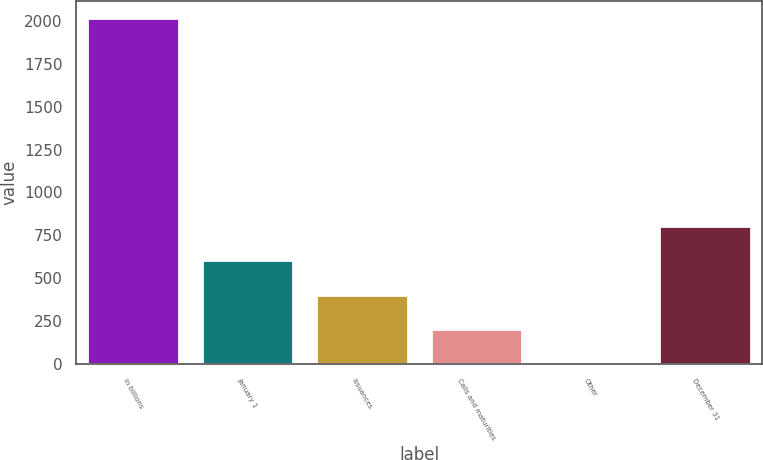<chart> <loc_0><loc_0><loc_500><loc_500><bar_chart><fcel>In billions<fcel>January 1<fcel>Issuances<fcel>Calls and maturities<fcel>Other<fcel>December 31<nl><fcel>2014<fcel>604.34<fcel>402.96<fcel>201.58<fcel>0.2<fcel>805.72<nl></chart> 